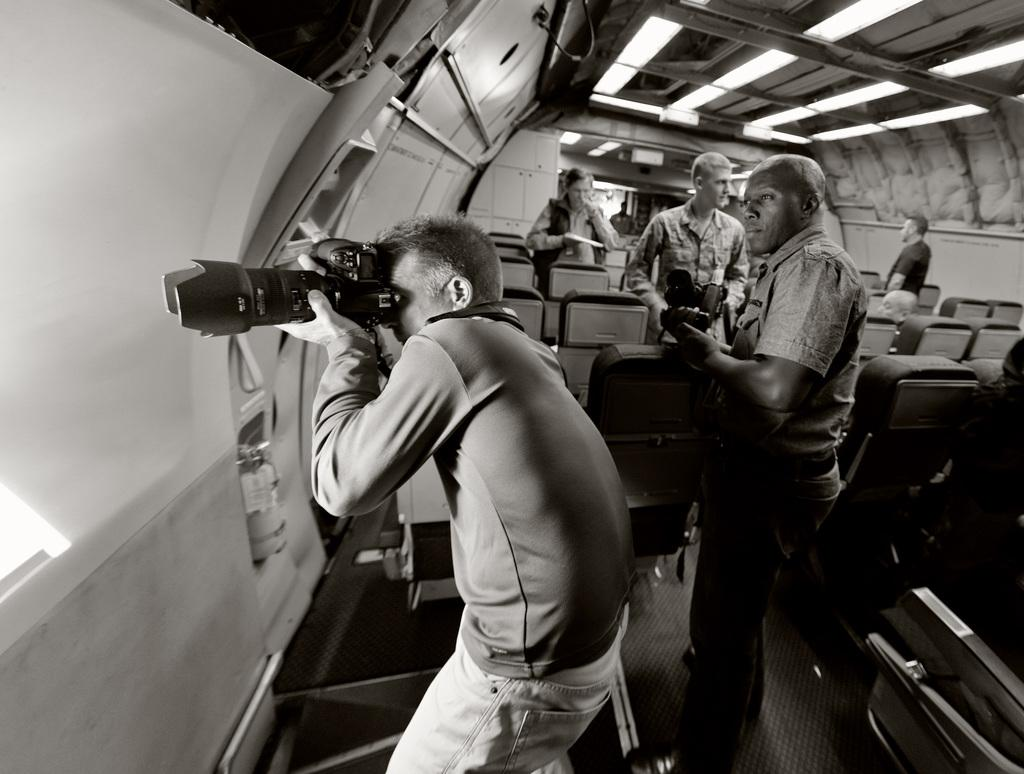How many people are in the image? There are people in the image, but the exact number is not specified. What objects are present in the image that people might sit on? Chairs are present in the image that people might sit on. What is a person in the image holding? A person in the image is holding a camera. Are there any cobwebs visible in the image? There is no mention of cobwebs in the provided facts, so we cannot determine if any are present in the image. How many balls are being juggled by the person holding the camera? There is no mention of balls or juggling in the provided facts, so we cannot determine if any are present in the image. 